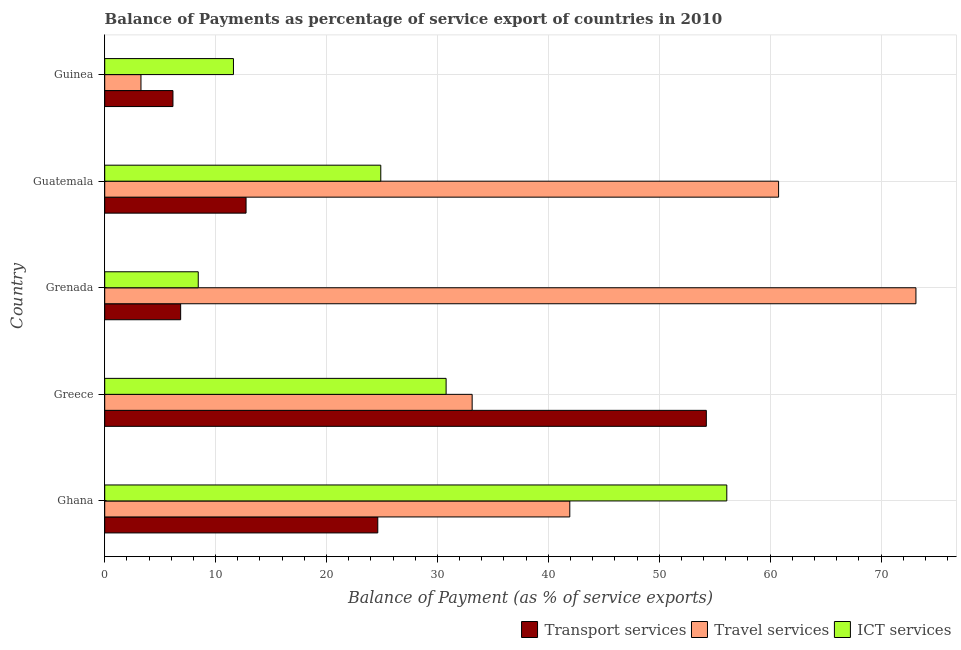How many different coloured bars are there?
Offer a terse response. 3. Are the number of bars per tick equal to the number of legend labels?
Your answer should be compact. Yes. How many bars are there on the 4th tick from the top?
Give a very brief answer. 3. How many bars are there on the 1st tick from the bottom?
Keep it short and to the point. 3. What is the label of the 1st group of bars from the top?
Give a very brief answer. Guinea. In how many cases, is the number of bars for a given country not equal to the number of legend labels?
Provide a succinct answer. 0. What is the balance of payment of transport services in Ghana?
Offer a very short reply. 24.62. Across all countries, what is the maximum balance of payment of ict services?
Offer a terse response. 56.09. Across all countries, what is the minimum balance of payment of travel services?
Your answer should be very brief. 3.27. In which country was the balance of payment of transport services minimum?
Ensure brevity in your answer.  Guinea. What is the total balance of payment of ict services in the graph?
Your answer should be compact. 131.81. What is the difference between the balance of payment of transport services in Ghana and that in Greece?
Ensure brevity in your answer.  -29.62. What is the difference between the balance of payment of ict services in Grenada and the balance of payment of transport services in Greece?
Provide a succinct answer. -45.81. What is the average balance of payment of travel services per country?
Give a very brief answer. 42.45. What is the difference between the balance of payment of travel services and balance of payment of ict services in Grenada?
Offer a terse response. 64.71. In how many countries, is the balance of payment of transport services greater than 54 %?
Make the answer very short. 1. What is the ratio of the balance of payment of travel services in Ghana to that in Guinea?
Your response must be concise. 12.83. What is the difference between the highest and the second highest balance of payment of ict services?
Give a very brief answer. 25.31. What is the difference between the highest and the lowest balance of payment of ict services?
Your answer should be compact. 47.66. In how many countries, is the balance of payment of transport services greater than the average balance of payment of transport services taken over all countries?
Provide a short and direct response. 2. What does the 3rd bar from the top in Guinea represents?
Offer a very short reply. Transport services. What does the 3rd bar from the bottom in Greece represents?
Your answer should be compact. ICT services. Is it the case that in every country, the sum of the balance of payment of transport services and balance of payment of travel services is greater than the balance of payment of ict services?
Keep it short and to the point. No. How many bars are there?
Your response must be concise. 15. Are all the bars in the graph horizontal?
Your response must be concise. Yes. How many countries are there in the graph?
Offer a terse response. 5. Does the graph contain grids?
Provide a succinct answer. Yes. How are the legend labels stacked?
Ensure brevity in your answer.  Horizontal. What is the title of the graph?
Provide a succinct answer. Balance of Payments as percentage of service export of countries in 2010. What is the label or title of the X-axis?
Ensure brevity in your answer.  Balance of Payment (as % of service exports). What is the Balance of Payment (as % of service exports) of Transport services in Ghana?
Ensure brevity in your answer.  24.62. What is the Balance of Payment (as % of service exports) in Travel services in Ghana?
Your answer should be compact. 41.94. What is the Balance of Payment (as % of service exports) of ICT services in Ghana?
Your response must be concise. 56.09. What is the Balance of Payment (as % of service exports) of Transport services in Greece?
Your answer should be compact. 54.25. What is the Balance of Payment (as % of service exports) of Travel services in Greece?
Offer a very short reply. 33.13. What is the Balance of Payment (as % of service exports) of ICT services in Greece?
Ensure brevity in your answer.  30.78. What is the Balance of Payment (as % of service exports) of Transport services in Grenada?
Your answer should be very brief. 6.85. What is the Balance of Payment (as % of service exports) in Travel services in Grenada?
Make the answer very short. 73.15. What is the Balance of Payment (as % of service exports) in ICT services in Grenada?
Keep it short and to the point. 8.43. What is the Balance of Payment (as % of service exports) of Transport services in Guatemala?
Offer a very short reply. 12.74. What is the Balance of Payment (as % of service exports) in Travel services in Guatemala?
Make the answer very short. 60.76. What is the Balance of Payment (as % of service exports) in ICT services in Guatemala?
Give a very brief answer. 24.89. What is the Balance of Payment (as % of service exports) of Transport services in Guinea?
Give a very brief answer. 6.15. What is the Balance of Payment (as % of service exports) of Travel services in Guinea?
Provide a succinct answer. 3.27. What is the Balance of Payment (as % of service exports) of ICT services in Guinea?
Keep it short and to the point. 11.61. Across all countries, what is the maximum Balance of Payment (as % of service exports) in Transport services?
Your answer should be compact. 54.25. Across all countries, what is the maximum Balance of Payment (as % of service exports) in Travel services?
Your response must be concise. 73.15. Across all countries, what is the maximum Balance of Payment (as % of service exports) of ICT services?
Keep it short and to the point. 56.09. Across all countries, what is the minimum Balance of Payment (as % of service exports) of Transport services?
Give a very brief answer. 6.15. Across all countries, what is the minimum Balance of Payment (as % of service exports) in Travel services?
Provide a short and direct response. 3.27. Across all countries, what is the minimum Balance of Payment (as % of service exports) in ICT services?
Provide a short and direct response. 8.43. What is the total Balance of Payment (as % of service exports) in Transport services in the graph?
Give a very brief answer. 104.61. What is the total Balance of Payment (as % of service exports) of Travel services in the graph?
Offer a terse response. 212.24. What is the total Balance of Payment (as % of service exports) of ICT services in the graph?
Provide a short and direct response. 131.81. What is the difference between the Balance of Payment (as % of service exports) of Transport services in Ghana and that in Greece?
Offer a terse response. -29.62. What is the difference between the Balance of Payment (as % of service exports) in Travel services in Ghana and that in Greece?
Offer a terse response. 8.8. What is the difference between the Balance of Payment (as % of service exports) of ICT services in Ghana and that in Greece?
Provide a succinct answer. 25.31. What is the difference between the Balance of Payment (as % of service exports) in Transport services in Ghana and that in Grenada?
Ensure brevity in your answer.  17.77. What is the difference between the Balance of Payment (as % of service exports) of Travel services in Ghana and that in Grenada?
Your answer should be very brief. -31.21. What is the difference between the Balance of Payment (as % of service exports) of ICT services in Ghana and that in Grenada?
Make the answer very short. 47.66. What is the difference between the Balance of Payment (as % of service exports) in Transport services in Ghana and that in Guatemala?
Your response must be concise. 11.88. What is the difference between the Balance of Payment (as % of service exports) in Travel services in Ghana and that in Guatemala?
Your response must be concise. -18.83. What is the difference between the Balance of Payment (as % of service exports) of ICT services in Ghana and that in Guatemala?
Give a very brief answer. 31.2. What is the difference between the Balance of Payment (as % of service exports) of Transport services in Ghana and that in Guinea?
Make the answer very short. 18.47. What is the difference between the Balance of Payment (as % of service exports) of Travel services in Ghana and that in Guinea?
Provide a succinct answer. 38.67. What is the difference between the Balance of Payment (as % of service exports) in ICT services in Ghana and that in Guinea?
Your answer should be compact. 44.48. What is the difference between the Balance of Payment (as % of service exports) in Transport services in Greece and that in Grenada?
Your response must be concise. 47.4. What is the difference between the Balance of Payment (as % of service exports) in Travel services in Greece and that in Grenada?
Your answer should be very brief. -40.01. What is the difference between the Balance of Payment (as % of service exports) of ICT services in Greece and that in Grenada?
Keep it short and to the point. 22.35. What is the difference between the Balance of Payment (as % of service exports) in Transport services in Greece and that in Guatemala?
Ensure brevity in your answer.  41.5. What is the difference between the Balance of Payment (as % of service exports) in Travel services in Greece and that in Guatemala?
Your answer should be very brief. -27.63. What is the difference between the Balance of Payment (as % of service exports) in ICT services in Greece and that in Guatemala?
Provide a succinct answer. 5.89. What is the difference between the Balance of Payment (as % of service exports) of Transport services in Greece and that in Guinea?
Your answer should be very brief. 48.09. What is the difference between the Balance of Payment (as % of service exports) of Travel services in Greece and that in Guinea?
Keep it short and to the point. 29.86. What is the difference between the Balance of Payment (as % of service exports) of ICT services in Greece and that in Guinea?
Provide a succinct answer. 19.17. What is the difference between the Balance of Payment (as % of service exports) in Transport services in Grenada and that in Guatemala?
Offer a very short reply. -5.9. What is the difference between the Balance of Payment (as % of service exports) of Travel services in Grenada and that in Guatemala?
Offer a terse response. 12.38. What is the difference between the Balance of Payment (as % of service exports) in ICT services in Grenada and that in Guatemala?
Provide a short and direct response. -16.46. What is the difference between the Balance of Payment (as % of service exports) of Transport services in Grenada and that in Guinea?
Give a very brief answer. 0.69. What is the difference between the Balance of Payment (as % of service exports) of Travel services in Grenada and that in Guinea?
Your answer should be very brief. 69.88. What is the difference between the Balance of Payment (as % of service exports) of ICT services in Grenada and that in Guinea?
Your answer should be very brief. -3.18. What is the difference between the Balance of Payment (as % of service exports) in Transport services in Guatemala and that in Guinea?
Make the answer very short. 6.59. What is the difference between the Balance of Payment (as % of service exports) of Travel services in Guatemala and that in Guinea?
Your response must be concise. 57.49. What is the difference between the Balance of Payment (as % of service exports) in ICT services in Guatemala and that in Guinea?
Provide a short and direct response. 13.28. What is the difference between the Balance of Payment (as % of service exports) of Transport services in Ghana and the Balance of Payment (as % of service exports) of Travel services in Greece?
Provide a succinct answer. -8.51. What is the difference between the Balance of Payment (as % of service exports) in Transport services in Ghana and the Balance of Payment (as % of service exports) in ICT services in Greece?
Offer a very short reply. -6.16. What is the difference between the Balance of Payment (as % of service exports) of Travel services in Ghana and the Balance of Payment (as % of service exports) of ICT services in Greece?
Keep it short and to the point. 11.15. What is the difference between the Balance of Payment (as % of service exports) in Transport services in Ghana and the Balance of Payment (as % of service exports) in Travel services in Grenada?
Ensure brevity in your answer.  -48.52. What is the difference between the Balance of Payment (as % of service exports) in Transport services in Ghana and the Balance of Payment (as % of service exports) in ICT services in Grenada?
Your answer should be very brief. 16.19. What is the difference between the Balance of Payment (as % of service exports) of Travel services in Ghana and the Balance of Payment (as % of service exports) of ICT services in Grenada?
Provide a short and direct response. 33.5. What is the difference between the Balance of Payment (as % of service exports) of Transport services in Ghana and the Balance of Payment (as % of service exports) of Travel services in Guatemala?
Ensure brevity in your answer.  -36.14. What is the difference between the Balance of Payment (as % of service exports) in Transport services in Ghana and the Balance of Payment (as % of service exports) in ICT services in Guatemala?
Your answer should be very brief. -0.27. What is the difference between the Balance of Payment (as % of service exports) of Travel services in Ghana and the Balance of Payment (as % of service exports) of ICT services in Guatemala?
Ensure brevity in your answer.  17.04. What is the difference between the Balance of Payment (as % of service exports) in Transport services in Ghana and the Balance of Payment (as % of service exports) in Travel services in Guinea?
Your answer should be very brief. 21.35. What is the difference between the Balance of Payment (as % of service exports) in Transport services in Ghana and the Balance of Payment (as % of service exports) in ICT services in Guinea?
Keep it short and to the point. 13.01. What is the difference between the Balance of Payment (as % of service exports) of Travel services in Ghana and the Balance of Payment (as % of service exports) of ICT services in Guinea?
Offer a very short reply. 30.33. What is the difference between the Balance of Payment (as % of service exports) in Transport services in Greece and the Balance of Payment (as % of service exports) in Travel services in Grenada?
Make the answer very short. -18.9. What is the difference between the Balance of Payment (as % of service exports) in Transport services in Greece and the Balance of Payment (as % of service exports) in ICT services in Grenada?
Your answer should be compact. 45.81. What is the difference between the Balance of Payment (as % of service exports) in Travel services in Greece and the Balance of Payment (as % of service exports) in ICT services in Grenada?
Make the answer very short. 24.7. What is the difference between the Balance of Payment (as % of service exports) in Transport services in Greece and the Balance of Payment (as % of service exports) in Travel services in Guatemala?
Provide a short and direct response. -6.52. What is the difference between the Balance of Payment (as % of service exports) in Transport services in Greece and the Balance of Payment (as % of service exports) in ICT services in Guatemala?
Keep it short and to the point. 29.35. What is the difference between the Balance of Payment (as % of service exports) of Travel services in Greece and the Balance of Payment (as % of service exports) of ICT services in Guatemala?
Your answer should be very brief. 8.24. What is the difference between the Balance of Payment (as % of service exports) of Transport services in Greece and the Balance of Payment (as % of service exports) of Travel services in Guinea?
Ensure brevity in your answer.  50.98. What is the difference between the Balance of Payment (as % of service exports) of Transport services in Greece and the Balance of Payment (as % of service exports) of ICT services in Guinea?
Make the answer very short. 42.64. What is the difference between the Balance of Payment (as % of service exports) in Travel services in Greece and the Balance of Payment (as % of service exports) in ICT services in Guinea?
Ensure brevity in your answer.  21.52. What is the difference between the Balance of Payment (as % of service exports) in Transport services in Grenada and the Balance of Payment (as % of service exports) in Travel services in Guatemala?
Offer a very short reply. -53.91. What is the difference between the Balance of Payment (as % of service exports) of Transport services in Grenada and the Balance of Payment (as % of service exports) of ICT services in Guatemala?
Your answer should be compact. -18.04. What is the difference between the Balance of Payment (as % of service exports) in Travel services in Grenada and the Balance of Payment (as % of service exports) in ICT services in Guatemala?
Offer a terse response. 48.25. What is the difference between the Balance of Payment (as % of service exports) in Transport services in Grenada and the Balance of Payment (as % of service exports) in Travel services in Guinea?
Your answer should be very brief. 3.58. What is the difference between the Balance of Payment (as % of service exports) of Transport services in Grenada and the Balance of Payment (as % of service exports) of ICT services in Guinea?
Offer a terse response. -4.76. What is the difference between the Balance of Payment (as % of service exports) of Travel services in Grenada and the Balance of Payment (as % of service exports) of ICT services in Guinea?
Your answer should be compact. 61.54. What is the difference between the Balance of Payment (as % of service exports) of Transport services in Guatemala and the Balance of Payment (as % of service exports) of Travel services in Guinea?
Your response must be concise. 9.48. What is the difference between the Balance of Payment (as % of service exports) of Transport services in Guatemala and the Balance of Payment (as % of service exports) of ICT services in Guinea?
Your response must be concise. 1.14. What is the difference between the Balance of Payment (as % of service exports) in Travel services in Guatemala and the Balance of Payment (as % of service exports) in ICT services in Guinea?
Offer a very short reply. 49.15. What is the average Balance of Payment (as % of service exports) in Transport services per country?
Your response must be concise. 20.92. What is the average Balance of Payment (as % of service exports) in Travel services per country?
Your response must be concise. 42.45. What is the average Balance of Payment (as % of service exports) of ICT services per country?
Your answer should be compact. 26.36. What is the difference between the Balance of Payment (as % of service exports) of Transport services and Balance of Payment (as % of service exports) of Travel services in Ghana?
Provide a short and direct response. -17.31. What is the difference between the Balance of Payment (as % of service exports) in Transport services and Balance of Payment (as % of service exports) in ICT services in Ghana?
Your response must be concise. -31.47. What is the difference between the Balance of Payment (as % of service exports) in Travel services and Balance of Payment (as % of service exports) in ICT services in Ghana?
Your answer should be very brief. -14.16. What is the difference between the Balance of Payment (as % of service exports) in Transport services and Balance of Payment (as % of service exports) in Travel services in Greece?
Offer a very short reply. 21.12. What is the difference between the Balance of Payment (as % of service exports) of Transport services and Balance of Payment (as % of service exports) of ICT services in Greece?
Provide a short and direct response. 23.46. What is the difference between the Balance of Payment (as % of service exports) of Travel services and Balance of Payment (as % of service exports) of ICT services in Greece?
Ensure brevity in your answer.  2.35. What is the difference between the Balance of Payment (as % of service exports) of Transport services and Balance of Payment (as % of service exports) of Travel services in Grenada?
Your response must be concise. -66.3. What is the difference between the Balance of Payment (as % of service exports) in Transport services and Balance of Payment (as % of service exports) in ICT services in Grenada?
Ensure brevity in your answer.  -1.59. What is the difference between the Balance of Payment (as % of service exports) in Travel services and Balance of Payment (as % of service exports) in ICT services in Grenada?
Keep it short and to the point. 64.71. What is the difference between the Balance of Payment (as % of service exports) of Transport services and Balance of Payment (as % of service exports) of Travel services in Guatemala?
Make the answer very short. -48.02. What is the difference between the Balance of Payment (as % of service exports) in Transport services and Balance of Payment (as % of service exports) in ICT services in Guatemala?
Keep it short and to the point. -12.15. What is the difference between the Balance of Payment (as % of service exports) of Travel services and Balance of Payment (as % of service exports) of ICT services in Guatemala?
Provide a succinct answer. 35.87. What is the difference between the Balance of Payment (as % of service exports) in Transport services and Balance of Payment (as % of service exports) in Travel services in Guinea?
Ensure brevity in your answer.  2.88. What is the difference between the Balance of Payment (as % of service exports) in Transport services and Balance of Payment (as % of service exports) in ICT services in Guinea?
Give a very brief answer. -5.46. What is the difference between the Balance of Payment (as % of service exports) in Travel services and Balance of Payment (as % of service exports) in ICT services in Guinea?
Provide a short and direct response. -8.34. What is the ratio of the Balance of Payment (as % of service exports) in Transport services in Ghana to that in Greece?
Provide a short and direct response. 0.45. What is the ratio of the Balance of Payment (as % of service exports) of Travel services in Ghana to that in Greece?
Your answer should be very brief. 1.27. What is the ratio of the Balance of Payment (as % of service exports) of ICT services in Ghana to that in Greece?
Your answer should be very brief. 1.82. What is the ratio of the Balance of Payment (as % of service exports) in Transport services in Ghana to that in Grenada?
Offer a very short reply. 3.6. What is the ratio of the Balance of Payment (as % of service exports) of Travel services in Ghana to that in Grenada?
Your answer should be compact. 0.57. What is the ratio of the Balance of Payment (as % of service exports) in ICT services in Ghana to that in Grenada?
Give a very brief answer. 6.65. What is the ratio of the Balance of Payment (as % of service exports) in Transport services in Ghana to that in Guatemala?
Keep it short and to the point. 1.93. What is the ratio of the Balance of Payment (as % of service exports) of Travel services in Ghana to that in Guatemala?
Give a very brief answer. 0.69. What is the ratio of the Balance of Payment (as % of service exports) of ICT services in Ghana to that in Guatemala?
Keep it short and to the point. 2.25. What is the ratio of the Balance of Payment (as % of service exports) of Transport services in Ghana to that in Guinea?
Offer a very short reply. 4. What is the ratio of the Balance of Payment (as % of service exports) in Travel services in Ghana to that in Guinea?
Your response must be concise. 12.83. What is the ratio of the Balance of Payment (as % of service exports) in ICT services in Ghana to that in Guinea?
Give a very brief answer. 4.83. What is the ratio of the Balance of Payment (as % of service exports) of Transport services in Greece to that in Grenada?
Provide a succinct answer. 7.92. What is the ratio of the Balance of Payment (as % of service exports) in Travel services in Greece to that in Grenada?
Make the answer very short. 0.45. What is the ratio of the Balance of Payment (as % of service exports) of ICT services in Greece to that in Grenada?
Give a very brief answer. 3.65. What is the ratio of the Balance of Payment (as % of service exports) in Transport services in Greece to that in Guatemala?
Provide a short and direct response. 4.26. What is the ratio of the Balance of Payment (as % of service exports) of Travel services in Greece to that in Guatemala?
Keep it short and to the point. 0.55. What is the ratio of the Balance of Payment (as % of service exports) in ICT services in Greece to that in Guatemala?
Ensure brevity in your answer.  1.24. What is the ratio of the Balance of Payment (as % of service exports) in Transport services in Greece to that in Guinea?
Provide a succinct answer. 8.82. What is the ratio of the Balance of Payment (as % of service exports) in Travel services in Greece to that in Guinea?
Keep it short and to the point. 10.14. What is the ratio of the Balance of Payment (as % of service exports) in ICT services in Greece to that in Guinea?
Provide a short and direct response. 2.65. What is the ratio of the Balance of Payment (as % of service exports) in Transport services in Grenada to that in Guatemala?
Give a very brief answer. 0.54. What is the ratio of the Balance of Payment (as % of service exports) in Travel services in Grenada to that in Guatemala?
Your response must be concise. 1.2. What is the ratio of the Balance of Payment (as % of service exports) of ICT services in Grenada to that in Guatemala?
Give a very brief answer. 0.34. What is the ratio of the Balance of Payment (as % of service exports) of Transport services in Grenada to that in Guinea?
Offer a terse response. 1.11. What is the ratio of the Balance of Payment (as % of service exports) of Travel services in Grenada to that in Guinea?
Offer a terse response. 22.38. What is the ratio of the Balance of Payment (as % of service exports) in ICT services in Grenada to that in Guinea?
Make the answer very short. 0.73. What is the ratio of the Balance of Payment (as % of service exports) of Transport services in Guatemala to that in Guinea?
Your response must be concise. 2.07. What is the ratio of the Balance of Payment (as % of service exports) of Travel services in Guatemala to that in Guinea?
Ensure brevity in your answer.  18.59. What is the ratio of the Balance of Payment (as % of service exports) in ICT services in Guatemala to that in Guinea?
Your answer should be compact. 2.14. What is the difference between the highest and the second highest Balance of Payment (as % of service exports) in Transport services?
Provide a succinct answer. 29.62. What is the difference between the highest and the second highest Balance of Payment (as % of service exports) in Travel services?
Offer a terse response. 12.38. What is the difference between the highest and the second highest Balance of Payment (as % of service exports) in ICT services?
Your answer should be compact. 25.31. What is the difference between the highest and the lowest Balance of Payment (as % of service exports) of Transport services?
Provide a short and direct response. 48.09. What is the difference between the highest and the lowest Balance of Payment (as % of service exports) in Travel services?
Give a very brief answer. 69.88. What is the difference between the highest and the lowest Balance of Payment (as % of service exports) in ICT services?
Keep it short and to the point. 47.66. 